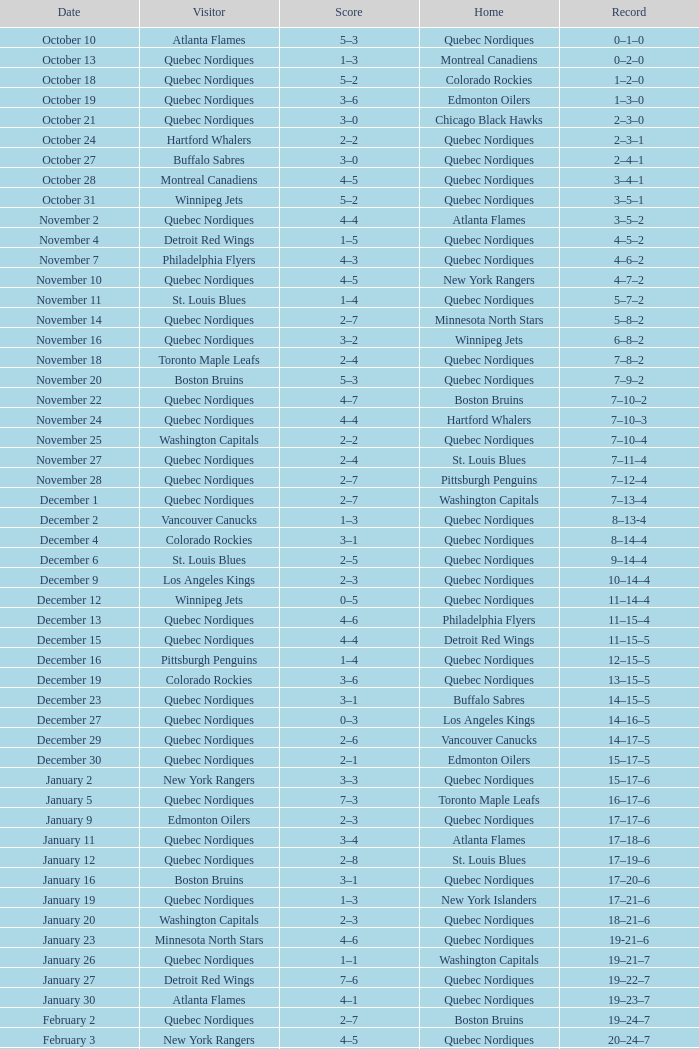Which Record has a Score of 2–4, and a Home of quebec nordiques? 7–8–2. 